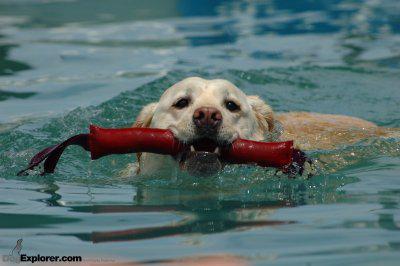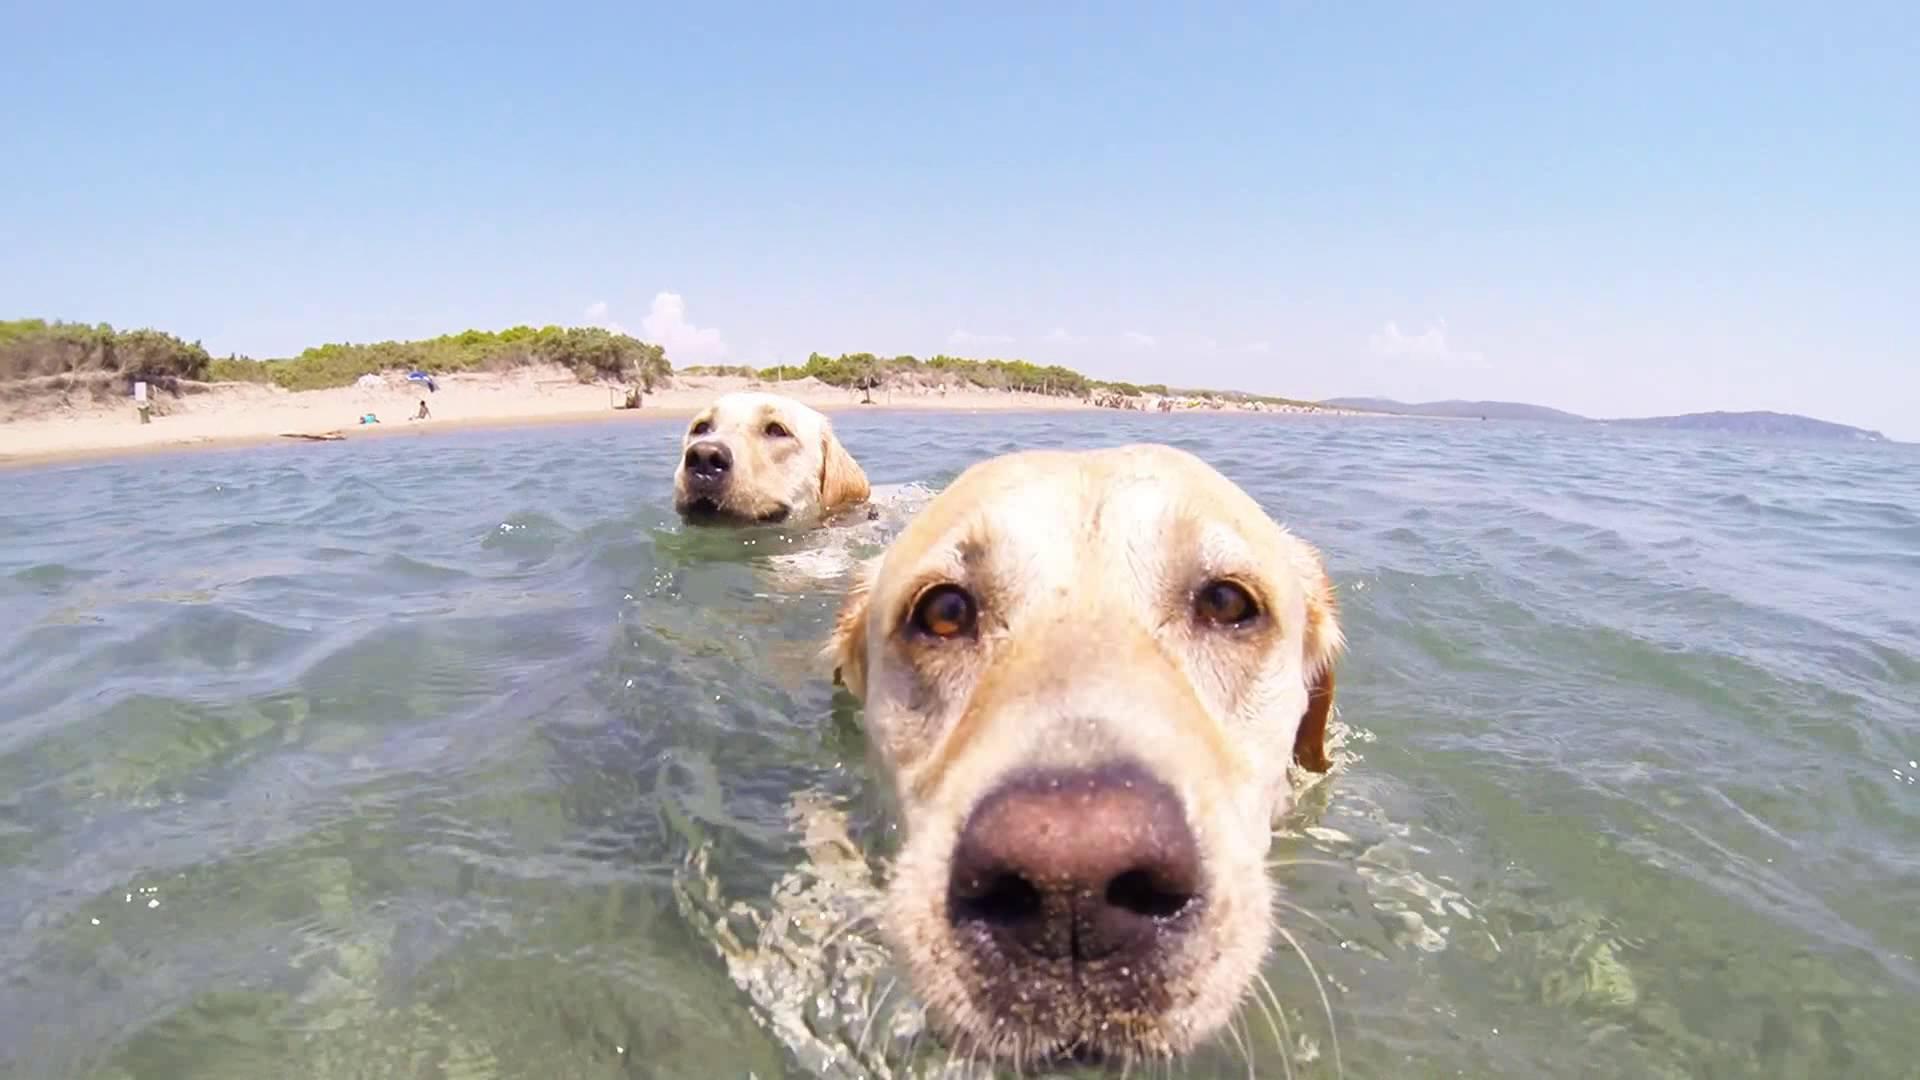The first image is the image on the left, the second image is the image on the right. For the images displayed, is the sentence "The dog in the image on the left is swimming with a rod in its mouth." factually correct? Answer yes or no. Yes. The first image is the image on the left, the second image is the image on the right. Examine the images to the left and right. Is the description "An image shows a swimming dog carrying a stick-shaped object in its mouth." accurate? Answer yes or no. Yes. 